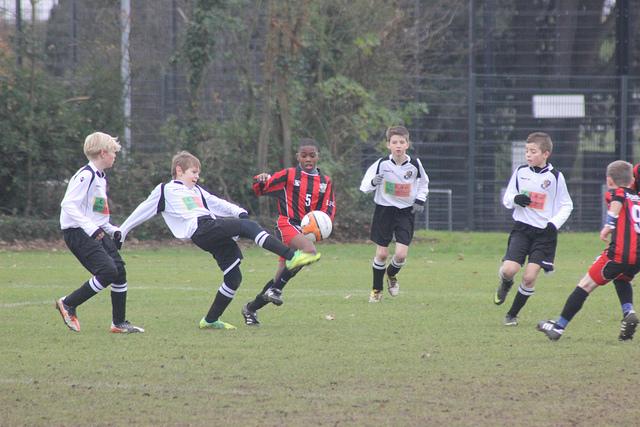Which game are they playing?
Be succinct. Soccer. How many kids are wearing black and white?
Be succinct. 4. What color are the shoes of the kid who is kicking the ball?
Write a very short answer. Yellow. What game are they playing?
Keep it brief. Soccer. Is this a women's sports team?
Answer briefly. No. What is in the air?
Short answer required. Soccer ball. What colors are the boys Jersey?
Quick response, please. White. 